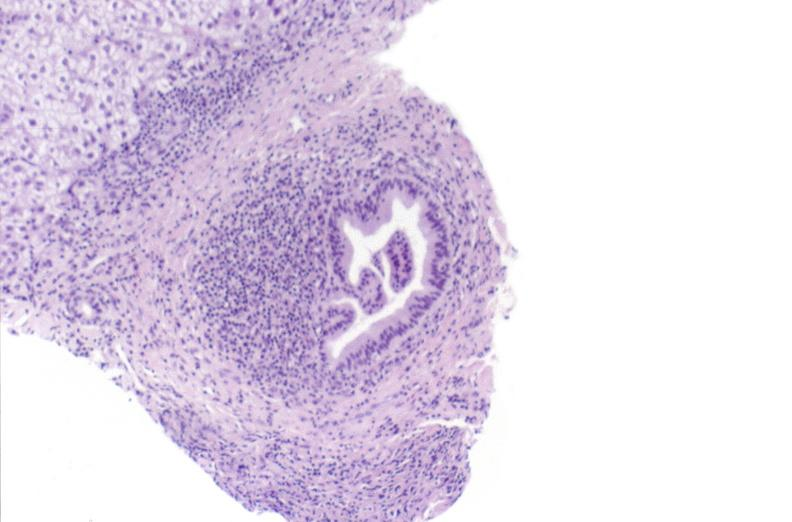does this image show primary biliary cirrhosis?
Answer the question using a single word or phrase. Yes 